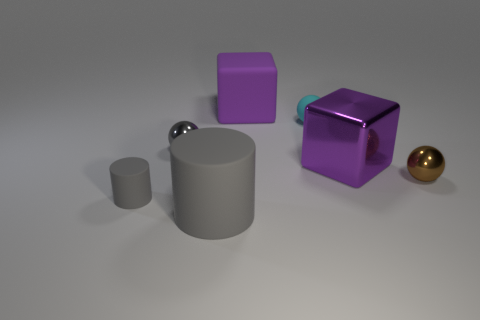There is another cylinder that is the same color as the big cylinder; what material is it?
Offer a very short reply. Rubber. There is a cylinder behind the big rubber cylinder; is its color the same as the large matte object that is in front of the gray metal thing?
Offer a terse response. Yes. What size is the other purple thing that is the same shape as the big metallic thing?
Make the answer very short. Large. The other big object that is the same shape as the purple metallic thing is what color?
Make the answer very short. Purple. What number of other things are there of the same color as the rubber cube?
Offer a very short reply. 1. There is a thing that is in front of the small cylinder; does it have the same shape as the tiny thing that is in front of the tiny brown thing?
Provide a succinct answer. Yes. Is the size of the gray metal object the same as the purple metallic thing?
Give a very brief answer. No. Is there a small object that has the same shape as the large purple metal object?
Offer a terse response. No. There is a cyan sphere; is its size the same as the cylinder that is right of the small matte cylinder?
Offer a terse response. No. How many things are cubes behind the purple metallic block or objects that are behind the cyan ball?
Offer a terse response. 1. 